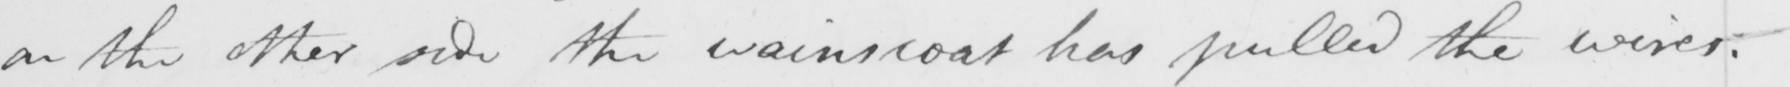Transcribe the text shown in this historical manuscript line. on the other side the wainscoat has pulled the wirer  . 